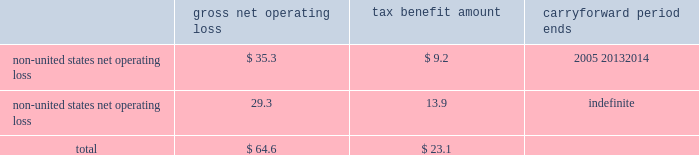Edwards lifesciences corporation notes to consolidated financial statements 2014 ( continued ) as of december 31 , 2004 , the company has approximately $ 64.6 million of non-united states tax net operating losses and $ 1.0 million of non-united states , non-expiring tax credits that are available for carryforward .
Net operating loss carryforwards , and the related carryforward periods , at december 31 , 2004 are summarized as follows ( in millions ) : gross net tax benefit carryforward operating loss amount period ends non-united states net operating loss****************** $ 35.3 $ 9.2 2005 20132014 non-united states net operating loss****************** 29.3 13.9 indefinite total ******************************************** $ 64.6 $ 23.1 a valuation allowance of $ 6.8 million has been provided for certain of the above carryforwards .
This valuation allowance reduces the deferred tax asset of $ 23.1 million to an amount that is more likely than not to be realized .
The company 2019s income tax returns in several locations are being examined by the local taxation authorities .
Management believes that adequate amounts of tax and related interest , if any , have been provided for any adjustments that may result from these examinations .
17 .
Legal proceedings on june 29 , 2000 , edwards lifesciences filed a lawsuit against st .
Jude medical , inc .
Alleging infringement of several edwards lifesciences united states patents .
This lawsuit was filed in the united states district court for the central district of california , seeking monetary damages and injunctive relief .
Pursuant to the terms of a january 7 , 2005 settlement agreement , edwards lifesciences was paid $ 5.5 million by st .
Jude , edwards lifesciences granted st .
Jude a paid-up license for certain of its heart valve therapy products and the lawsuit was dismissed .
The settlement will not have a material financial impact on the company .
On august 18 , 2003 , edwards lifesciences filed a lawsuit against medtronic , inc. , medtronic ave , cook , inc .
And w.l .
Gore & associates alleging infringement of a patent exclusively licensed to the company .
The lawsuit was filed in the united states district court for the northern district of california , seeking monetary damages and injunctive relief .
On september 2 , 2003 , a second patent exclusively licensed to the company was added to the lawsuit .
Each of the defendants has answered and asserted various affirmative defenses and counterclaims .
Discovery is proceeding .
In addition , edwards lifesciences is or may be a party to , or may be otherwise responsible for , pending or threatened lawsuits related primarily to products and services currently or formerly manufactured or performed , as applicable , by edwards lifesciences .
Such cases and claims raise difficult and complex factual and legal issues and are subject to many uncertainties and complexities , including , but not limited to , the facts and circumstances of each particular case or claim , the jurisdiction in which each suit is brought , and differences in applicable law .
Upon resolution of any pending legal matters , edwards lifesciences may incur charges in excess of presently established reserves .
While any such charge could have a material adverse impact on edwards lifesciences 2019 net income or cash flows in the period in which it is recorded or paid , management does not believe that any such charge would have a material adverse effect on edwards lifesciences 2019 financial position , results of operations or liquidity .
Edwards lifesciences is also subject to various environmental laws and regulations both within and outside of the united states .
The operations of edwards lifesciences , like those of other medical device companies , involve the use of substances regulated under environmental laws , primarily in manufacturing and sterilization processes .
While it is difficult to quantify the potential impact of compliance with environmental protection laws .
Edwards lifesciences corporation notes to consolidated financial statements 2014 ( continued ) as of december 31 , 2004 , the company has approximately $ 64.6 million of non-united states tax net operating losses and $ 1.0 million of non-united states , non-expiring tax credits that are available for carryforward .
Net operating loss carryforwards , and the related carryforward periods , at december 31 , 2004 are summarized as follows ( in millions ) : gross net tax benefit carryforward operating loss amount period ends non-united states net operating loss****************** $ 35.3 $ 9.2 2005 20132014 non-united states net operating loss****************** 29.3 13.9 indefinite total ******************************************** $ 64.6 $ 23.1 a valuation allowance of $ 6.8 million has been provided for certain of the above carryforwards .
This valuation allowance reduces the deferred tax asset of $ 23.1 million to an amount that is more likely than not to be realized .
The company 2019s income tax returns in several locations are being examined by the local taxation authorities .
Management believes that adequate amounts of tax and related interest , if any , have been provided for any adjustments that may result from these examinations .
17 .
Legal proceedings on june 29 , 2000 , edwards lifesciences filed a lawsuit against st .
Jude medical , inc .
Alleging infringement of several edwards lifesciences united states patents .
This lawsuit was filed in the united states district court for the central district of california , seeking monetary damages and injunctive relief .
Pursuant to the terms of a january 7 , 2005 settlement agreement , edwards lifesciences was paid $ 5.5 million by st .
Jude , edwards lifesciences granted st .
Jude a paid-up license for certain of its heart valve therapy products and the lawsuit was dismissed .
The settlement will not have a material financial impact on the company .
On august 18 , 2003 , edwards lifesciences filed a lawsuit against medtronic , inc. , medtronic ave , cook , inc .
And w.l .
Gore & associates alleging infringement of a patent exclusively licensed to the company .
The lawsuit was filed in the united states district court for the northern district of california , seeking monetary damages and injunctive relief .
On september 2 , 2003 , a second patent exclusively licensed to the company was added to the lawsuit .
Each of the defendants has answered and asserted various affirmative defenses and counterclaims .
Discovery is proceeding .
In addition , edwards lifesciences is or may be a party to , or may be otherwise responsible for , pending or threatened lawsuits related primarily to products and services currently or formerly manufactured or performed , as applicable , by edwards lifesciences .
Such cases and claims raise difficult and complex factual and legal issues and are subject to many uncertainties and complexities , including , but not limited to , the facts and circumstances of each particular case or claim , the jurisdiction in which each suit is brought , and differences in applicable law .
Upon resolution of any pending legal matters , edwards lifesciences may incur charges in excess of presently established reserves .
While any such charge could have a material adverse impact on edwards lifesciences 2019 net income or cash flows in the period in which it is recorded or paid , management does not believe that any such charge would have a material adverse effect on edwards lifesciences 2019 financial position , results of operations or liquidity .
Edwards lifesciences is also subject to various environmental laws and regulations both within and outside of the united states .
The operations of edwards lifesciences , like those of other medical device companies , involve the use of substances regulated under environmental laws , primarily in manufacturing and sterilization processes .
While it is difficult to quantify the potential impact of compliance with environmental protection laws .
What is the percentage of the tax benefit compared to the gross net operating loss for the non-united states net operating loss of indefinite period? 
Computations: (13.9 / 29.3)
Answer: 0.4744. 